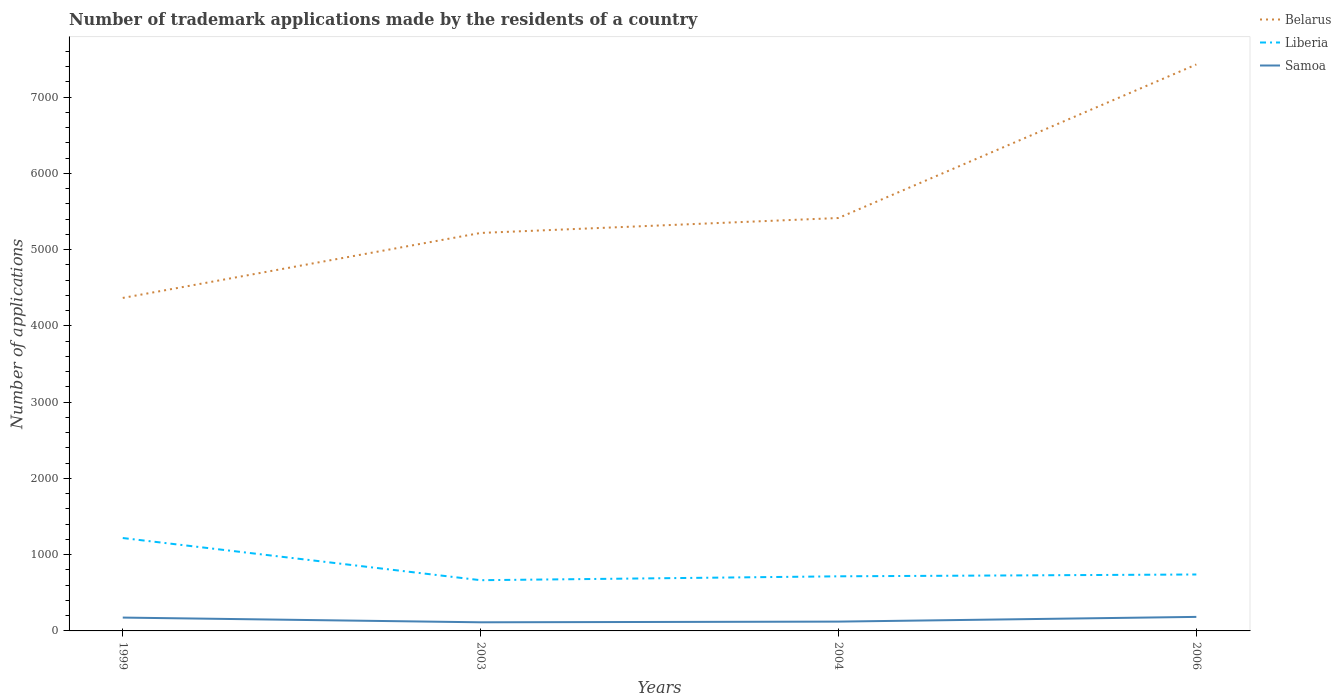How many different coloured lines are there?
Provide a short and direct response. 3. Does the line corresponding to Belarus intersect with the line corresponding to Samoa?
Offer a terse response. No. Is the number of lines equal to the number of legend labels?
Keep it short and to the point. Yes. Across all years, what is the maximum number of trademark applications made by the residents in Liberia?
Ensure brevity in your answer.  665. What is the difference between the highest and the second highest number of trademark applications made by the residents in Belarus?
Offer a very short reply. 3061. What is the difference between the highest and the lowest number of trademark applications made by the residents in Belarus?
Ensure brevity in your answer.  1. How many lines are there?
Your answer should be compact. 3. What is the difference between two consecutive major ticks on the Y-axis?
Your answer should be compact. 1000. Does the graph contain grids?
Give a very brief answer. No. Where does the legend appear in the graph?
Give a very brief answer. Top right. How many legend labels are there?
Ensure brevity in your answer.  3. How are the legend labels stacked?
Make the answer very short. Vertical. What is the title of the graph?
Ensure brevity in your answer.  Number of trademark applications made by the residents of a country. Does "Mexico" appear as one of the legend labels in the graph?
Your answer should be very brief. No. What is the label or title of the Y-axis?
Provide a succinct answer. Number of applications. What is the Number of applications of Belarus in 1999?
Your answer should be compact. 4366. What is the Number of applications in Liberia in 1999?
Provide a short and direct response. 1218. What is the Number of applications in Samoa in 1999?
Offer a terse response. 175. What is the Number of applications in Belarus in 2003?
Provide a succinct answer. 5218. What is the Number of applications of Liberia in 2003?
Make the answer very short. 665. What is the Number of applications in Samoa in 2003?
Your response must be concise. 113. What is the Number of applications of Belarus in 2004?
Offer a terse response. 5414. What is the Number of applications in Liberia in 2004?
Offer a terse response. 716. What is the Number of applications in Samoa in 2004?
Keep it short and to the point. 122. What is the Number of applications of Belarus in 2006?
Ensure brevity in your answer.  7427. What is the Number of applications of Liberia in 2006?
Make the answer very short. 740. What is the Number of applications of Samoa in 2006?
Give a very brief answer. 184. Across all years, what is the maximum Number of applications in Belarus?
Your answer should be very brief. 7427. Across all years, what is the maximum Number of applications in Liberia?
Provide a short and direct response. 1218. Across all years, what is the maximum Number of applications of Samoa?
Your answer should be compact. 184. Across all years, what is the minimum Number of applications in Belarus?
Keep it short and to the point. 4366. Across all years, what is the minimum Number of applications of Liberia?
Make the answer very short. 665. Across all years, what is the minimum Number of applications of Samoa?
Your answer should be very brief. 113. What is the total Number of applications in Belarus in the graph?
Give a very brief answer. 2.24e+04. What is the total Number of applications in Liberia in the graph?
Offer a terse response. 3339. What is the total Number of applications of Samoa in the graph?
Keep it short and to the point. 594. What is the difference between the Number of applications of Belarus in 1999 and that in 2003?
Give a very brief answer. -852. What is the difference between the Number of applications of Liberia in 1999 and that in 2003?
Keep it short and to the point. 553. What is the difference between the Number of applications of Samoa in 1999 and that in 2003?
Your answer should be very brief. 62. What is the difference between the Number of applications of Belarus in 1999 and that in 2004?
Your answer should be very brief. -1048. What is the difference between the Number of applications in Liberia in 1999 and that in 2004?
Keep it short and to the point. 502. What is the difference between the Number of applications in Samoa in 1999 and that in 2004?
Your answer should be very brief. 53. What is the difference between the Number of applications of Belarus in 1999 and that in 2006?
Make the answer very short. -3061. What is the difference between the Number of applications of Liberia in 1999 and that in 2006?
Provide a succinct answer. 478. What is the difference between the Number of applications of Samoa in 1999 and that in 2006?
Offer a very short reply. -9. What is the difference between the Number of applications in Belarus in 2003 and that in 2004?
Your answer should be compact. -196. What is the difference between the Number of applications of Liberia in 2003 and that in 2004?
Offer a very short reply. -51. What is the difference between the Number of applications of Samoa in 2003 and that in 2004?
Make the answer very short. -9. What is the difference between the Number of applications of Belarus in 2003 and that in 2006?
Make the answer very short. -2209. What is the difference between the Number of applications in Liberia in 2003 and that in 2006?
Ensure brevity in your answer.  -75. What is the difference between the Number of applications of Samoa in 2003 and that in 2006?
Offer a terse response. -71. What is the difference between the Number of applications of Belarus in 2004 and that in 2006?
Your answer should be compact. -2013. What is the difference between the Number of applications in Samoa in 2004 and that in 2006?
Provide a succinct answer. -62. What is the difference between the Number of applications of Belarus in 1999 and the Number of applications of Liberia in 2003?
Give a very brief answer. 3701. What is the difference between the Number of applications in Belarus in 1999 and the Number of applications in Samoa in 2003?
Provide a short and direct response. 4253. What is the difference between the Number of applications of Liberia in 1999 and the Number of applications of Samoa in 2003?
Your answer should be very brief. 1105. What is the difference between the Number of applications in Belarus in 1999 and the Number of applications in Liberia in 2004?
Keep it short and to the point. 3650. What is the difference between the Number of applications in Belarus in 1999 and the Number of applications in Samoa in 2004?
Your answer should be compact. 4244. What is the difference between the Number of applications of Liberia in 1999 and the Number of applications of Samoa in 2004?
Your response must be concise. 1096. What is the difference between the Number of applications in Belarus in 1999 and the Number of applications in Liberia in 2006?
Your response must be concise. 3626. What is the difference between the Number of applications in Belarus in 1999 and the Number of applications in Samoa in 2006?
Your answer should be very brief. 4182. What is the difference between the Number of applications of Liberia in 1999 and the Number of applications of Samoa in 2006?
Make the answer very short. 1034. What is the difference between the Number of applications of Belarus in 2003 and the Number of applications of Liberia in 2004?
Provide a succinct answer. 4502. What is the difference between the Number of applications of Belarus in 2003 and the Number of applications of Samoa in 2004?
Provide a succinct answer. 5096. What is the difference between the Number of applications of Liberia in 2003 and the Number of applications of Samoa in 2004?
Provide a short and direct response. 543. What is the difference between the Number of applications in Belarus in 2003 and the Number of applications in Liberia in 2006?
Your answer should be very brief. 4478. What is the difference between the Number of applications in Belarus in 2003 and the Number of applications in Samoa in 2006?
Offer a terse response. 5034. What is the difference between the Number of applications in Liberia in 2003 and the Number of applications in Samoa in 2006?
Your answer should be very brief. 481. What is the difference between the Number of applications in Belarus in 2004 and the Number of applications in Liberia in 2006?
Provide a succinct answer. 4674. What is the difference between the Number of applications of Belarus in 2004 and the Number of applications of Samoa in 2006?
Make the answer very short. 5230. What is the difference between the Number of applications in Liberia in 2004 and the Number of applications in Samoa in 2006?
Keep it short and to the point. 532. What is the average Number of applications of Belarus per year?
Offer a terse response. 5606.25. What is the average Number of applications of Liberia per year?
Provide a succinct answer. 834.75. What is the average Number of applications of Samoa per year?
Ensure brevity in your answer.  148.5. In the year 1999, what is the difference between the Number of applications in Belarus and Number of applications in Liberia?
Make the answer very short. 3148. In the year 1999, what is the difference between the Number of applications in Belarus and Number of applications in Samoa?
Provide a short and direct response. 4191. In the year 1999, what is the difference between the Number of applications of Liberia and Number of applications of Samoa?
Make the answer very short. 1043. In the year 2003, what is the difference between the Number of applications of Belarus and Number of applications of Liberia?
Offer a terse response. 4553. In the year 2003, what is the difference between the Number of applications of Belarus and Number of applications of Samoa?
Your answer should be very brief. 5105. In the year 2003, what is the difference between the Number of applications of Liberia and Number of applications of Samoa?
Give a very brief answer. 552. In the year 2004, what is the difference between the Number of applications in Belarus and Number of applications in Liberia?
Offer a very short reply. 4698. In the year 2004, what is the difference between the Number of applications in Belarus and Number of applications in Samoa?
Provide a succinct answer. 5292. In the year 2004, what is the difference between the Number of applications in Liberia and Number of applications in Samoa?
Offer a terse response. 594. In the year 2006, what is the difference between the Number of applications in Belarus and Number of applications in Liberia?
Offer a terse response. 6687. In the year 2006, what is the difference between the Number of applications in Belarus and Number of applications in Samoa?
Provide a succinct answer. 7243. In the year 2006, what is the difference between the Number of applications in Liberia and Number of applications in Samoa?
Your answer should be very brief. 556. What is the ratio of the Number of applications in Belarus in 1999 to that in 2003?
Offer a very short reply. 0.84. What is the ratio of the Number of applications of Liberia in 1999 to that in 2003?
Offer a very short reply. 1.83. What is the ratio of the Number of applications in Samoa in 1999 to that in 2003?
Keep it short and to the point. 1.55. What is the ratio of the Number of applications in Belarus in 1999 to that in 2004?
Give a very brief answer. 0.81. What is the ratio of the Number of applications of Liberia in 1999 to that in 2004?
Your response must be concise. 1.7. What is the ratio of the Number of applications of Samoa in 1999 to that in 2004?
Your answer should be very brief. 1.43. What is the ratio of the Number of applications in Belarus in 1999 to that in 2006?
Provide a short and direct response. 0.59. What is the ratio of the Number of applications of Liberia in 1999 to that in 2006?
Give a very brief answer. 1.65. What is the ratio of the Number of applications in Samoa in 1999 to that in 2006?
Your answer should be compact. 0.95. What is the ratio of the Number of applications in Belarus in 2003 to that in 2004?
Your answer should be very brief. 0.96. What is the ratio of the Number of applications of Liberia in 2003 to that in 2004?
Your answer should be compact. 0.93. What is the ratio of the Number of applications in Samoa in 2003 to that in 2004?
Give a very brief answer. 0.93. What is the ratio of the Number of applications in Belarus in 2003 to that in 2006?
Offer a very short reply. 0.7. What is the ratio of the Number of applications of Liberia in 2003 to that in 2006?
Offer a very short reply. 0.9. What is the ratio of the Number of applications in Samoa in 2003 to that in 2006?
Your answer should be compact. 0.61. What is the ratio of the Number of applications in Belarus in 2004 to that in 2006?
Offer a very short reply. 0.73. What is the ratio of the Number of applications of Liberia in 2004 to that in 2006?
Give a very brief answer. 0.97. What is the ratio of the Number of applications of Samoa in 2004 to that in 2006?
Provide a succinct answer. 0.66. What is the difference between the highest and the second highest Number of applications of Belarus?
Make the answer very short. 2013. What is the difference between the highest and the second highest Number of applications of Liberia?
Give a very brief answer. 478. What is the difference between the highest and the lowest Number of applications in Belarus?
Offer a terse response. 3061. What is the difference between the highest and the lowest Number of applications in Liberia?
Ensure brevity in your answer.  553. 